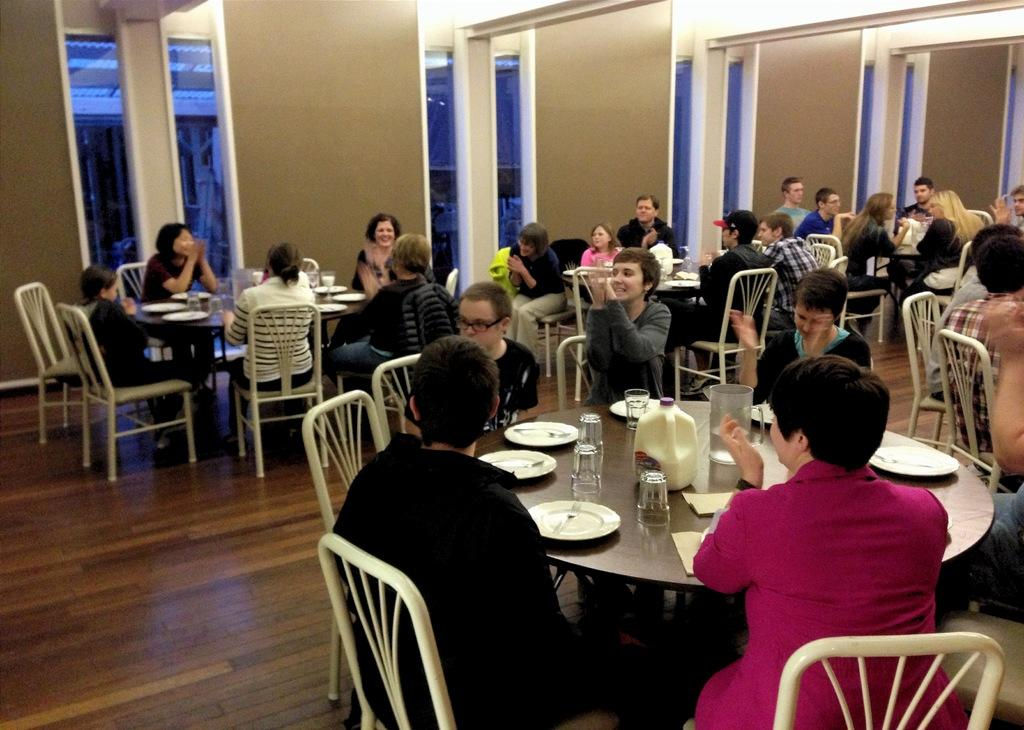What type of furniture is present in the image? There are tables in the image. What are the people sitting on in the image? There are people sitting on chairs in the image. What objects can be seen on the tables? There are plates, glasses, and bottles on the tables. Can you see any feathers on the tables in the image? There are no feathers present on the tables in the image. What type of basket is being used by the people in the image? There are no baskets present in the image. 